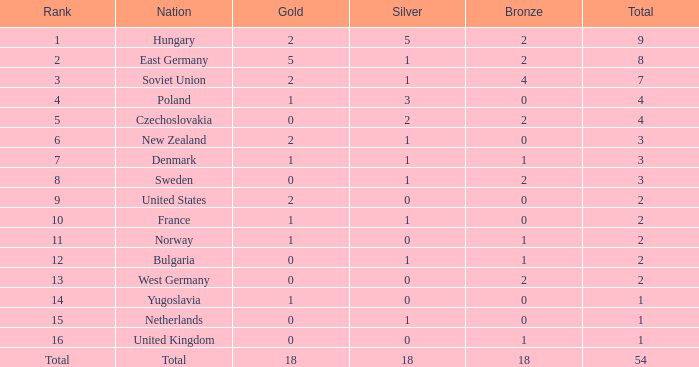What is the minimum total for those who have more than 14 but less than 18? 1.0. 